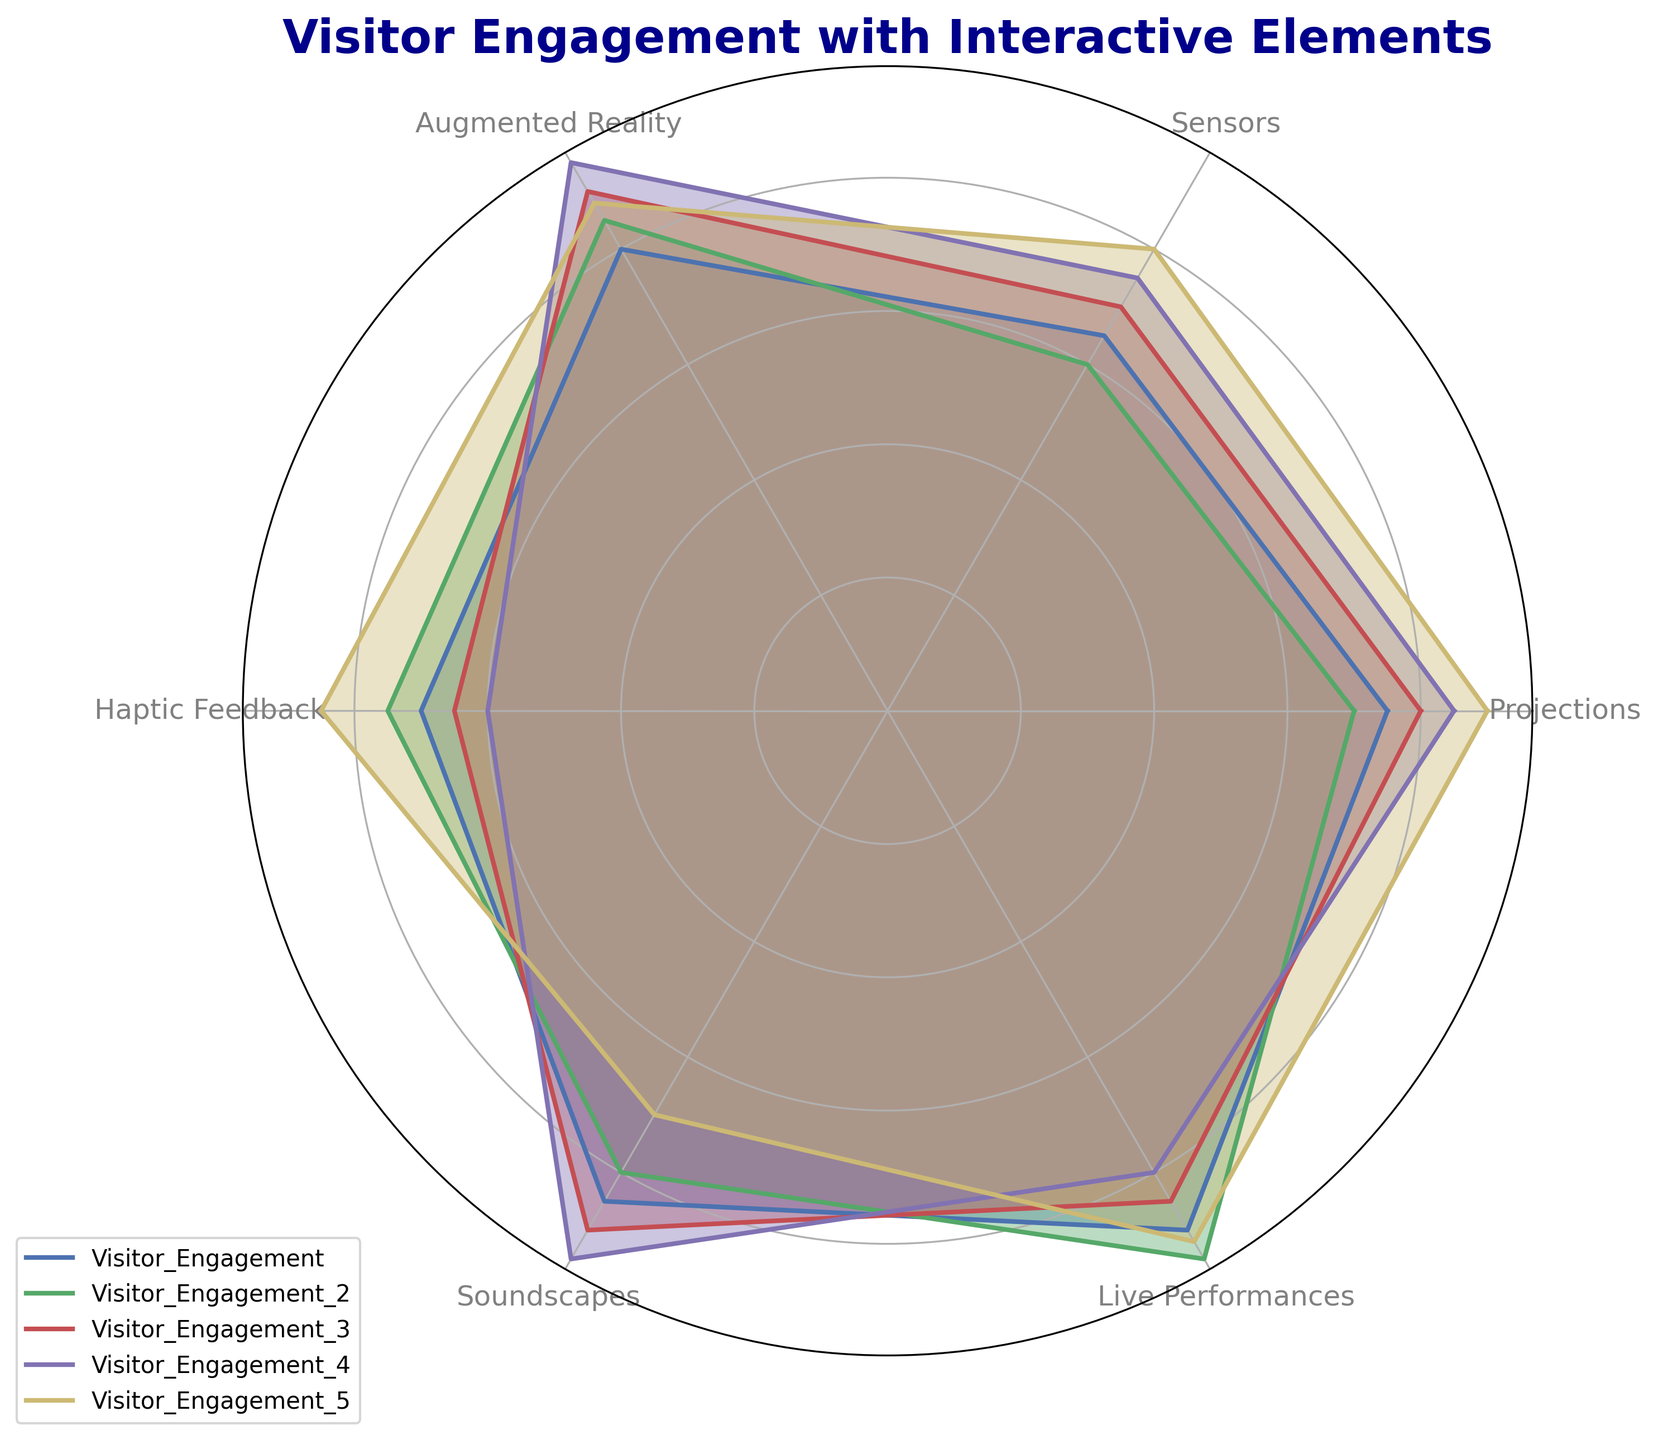Which interactive element has the highest visitor engagement across all categories? To determine the highest visitor engagement, observe the vertices on the radar chart. The 'Live Performances' category peaks across most datasets.
Answer: Live Performances How does visitor engagement with Haptic Feedback compare to Augmented Reality for Category Visitor_Engagement_3? Look at the data points on the radar chart for Visitor_Engagement_3. Haptic Feedback is at 65, while Augmented Reality is at 90, showing Augmented Reality is higher.
Answer: Augmented Reality is higher What is the average engagement level for Sensors across all categories? Sum the engagement levels for Sensors (65, 60, 70, 75, 80) and divide by the number of categories (5). (65 + 60 + 70 + 75 + 80) / 5 = 350 / 5 = 70
Answer: 70 Which category shows the least visitor engagement in Soundscapes? For each category, check the data points corresponding to Soundscapes. Visitor_Engagement_5 has the lowest point at 70.
Answer: Visitor_Engagement_5 Is the engagement level for Projections higher than Sensors in Category Visitor_Engagement_1? Compare the points of Projections (75) and Sensors (65) in Visitor_Engagement_1 on the radar chart. Projections are higher.
Answer: Yes Order categories by their engagement levels in Live Performances from highest to lowest. List engagement levels: Visitor_Engagement_2 (95), Visitor_Engagement_5 (92), Visitor_Engagement_1 (90), Visitor_Engagement_3 (85), and Visitor_Engagement_4 (80).
Answer: Visitor_Engagement_2, Visitor_Engagement_5, Visitor_Engagement_1, Visitor_Engagement_3, Visitor_Engagement_4 Which visual attributes indicate the highest engagement levels on the radar chart? Observe the longest vertices extending outwards from the center in each category. Vividly colored and extended vertices usually represent the highest engagement levels.
Answer: Longest vertices How does engagement in Augmented Reality differ between Visitor_Engagement_1 and Visitor_Engagement_4? Augmented Reality values for Visitor_Engagement_1 are 80 and for Visitor_Engagement_4 are 95, meaning Visitor_Engagement_4 has a higher engagement.
Answer: Visitor_Engagement_4 is higher Calculate the total engagement for Haptic Feedback across all categories. Add individual Haptic Feedback values (70, 75, 65, 60, 85): 70 + 75 + 65 + 60 + 85 = 355.
Answer: 355 Which category has the most balanced engagement across all interactive elements? Check for the category where the vertices are closest to each other in length, indicating similar engagement. Visitor_Engagement_1 and Visitor_Engagement_5 appear well-balanced, but Visitor_Engagement_1 is most balanced.
Answer: Visitor_Engagement_1 